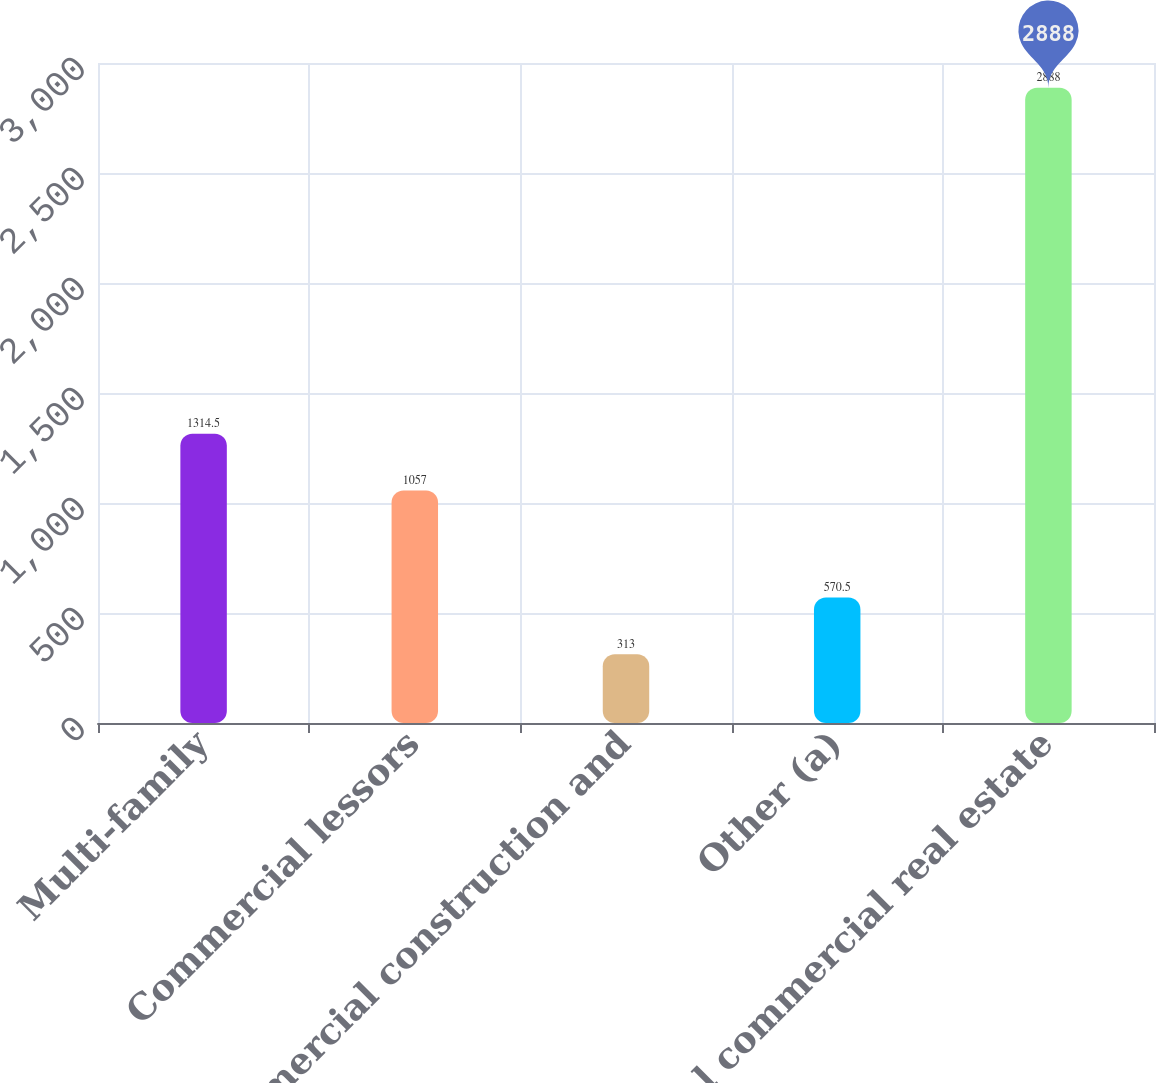Convert chart to OTSL. <chart><loc_0><loc_0><loc_500><loc_500><bar_chart><fcel>Multi-family<fcel>Commercial lessors<fcel>Commercial construction and<fcel>Other (a)<fcel>Total commercial real estate<nl><fcel>1314.5<fcel>1057<fcel>313<fcel>570.5<fcel>2888<nl></chart> 